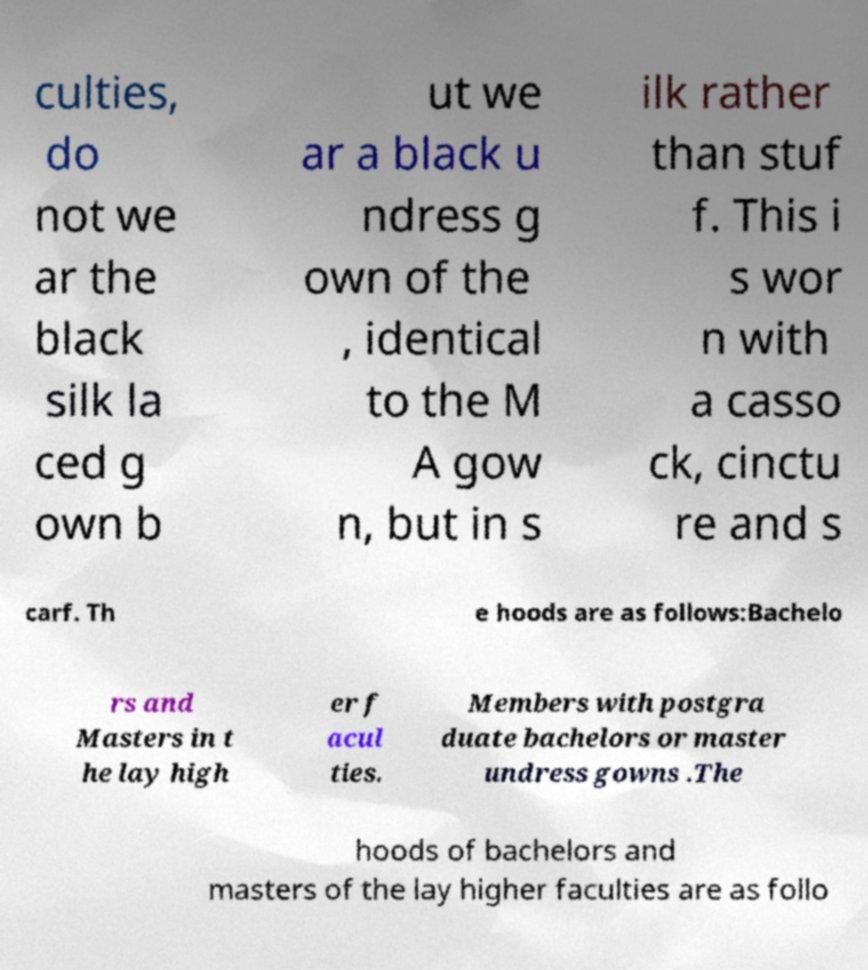Could you assist in decoding the text presented in this image and type it out clearly? culties, do not we ar the black silk la ced g own b ut we ar a black u ndress g own of the , identical to the M A gow n, but in s ilk rather than stuf f. This i s wor n with a casso ck, cinctu re and s carf. Th e hoods are as follows:Bachelo rs and Masters in t he lay high er f acul ties. Members with postgra duate bachelors or master undress gowns .The hoods of bachelors and masters of the lay higher faculties are as follo 